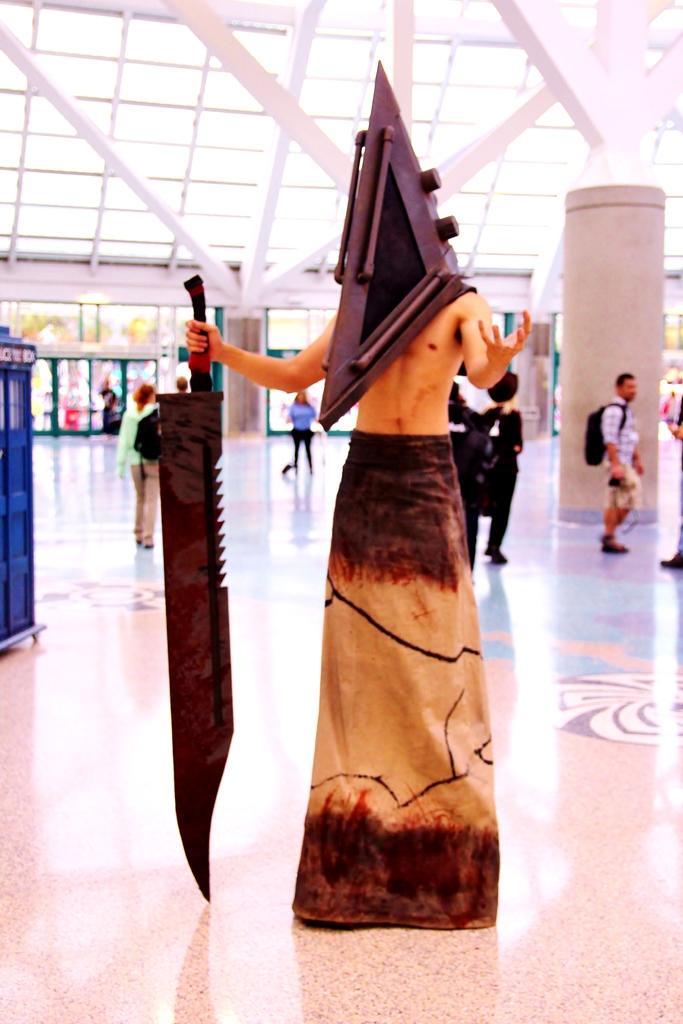How would you summarize this image in a sentence or two? In this image, we can see a person wearing a costume and holding a weapon. At the bottom, we can see the floor. Background there are few people, pillar and few objects. 